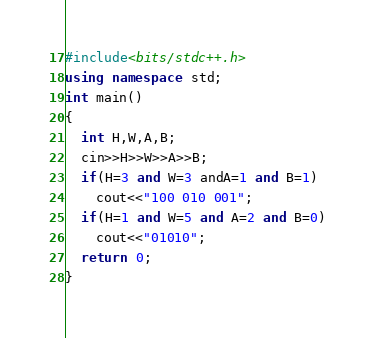Convert code to text. <code><loc_0><loc_0><loc_500><loc_500><_C++_>#include<bits/stdc++.h>
using namespace std;
int main()
{
  int H,W,A,B;
  cin>>H>>W>>A>>B;
  if(H=3 and W=3 andA=1 and B=1)
    cout<<"100 010 001";
  if(H=1 and W=5 and A=2 and B=0)
    cout<<"01010";
  return 0;
}</code> 